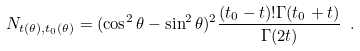<formula> <loc_0><loc_0><loc_500><loc_500>N _ { t ( \theta ) , t _ { 0 } ( \theta ) } = ( \cos ^ { 2 } \theta - \sin ^ { 2 } \theta ) ^ { 2 } \frac { ( t _ { 0 } - t ) ! \Gamma ( t _ { 0 } + t ) } { \Gamma ( 2 t ) } \ .</formula> 